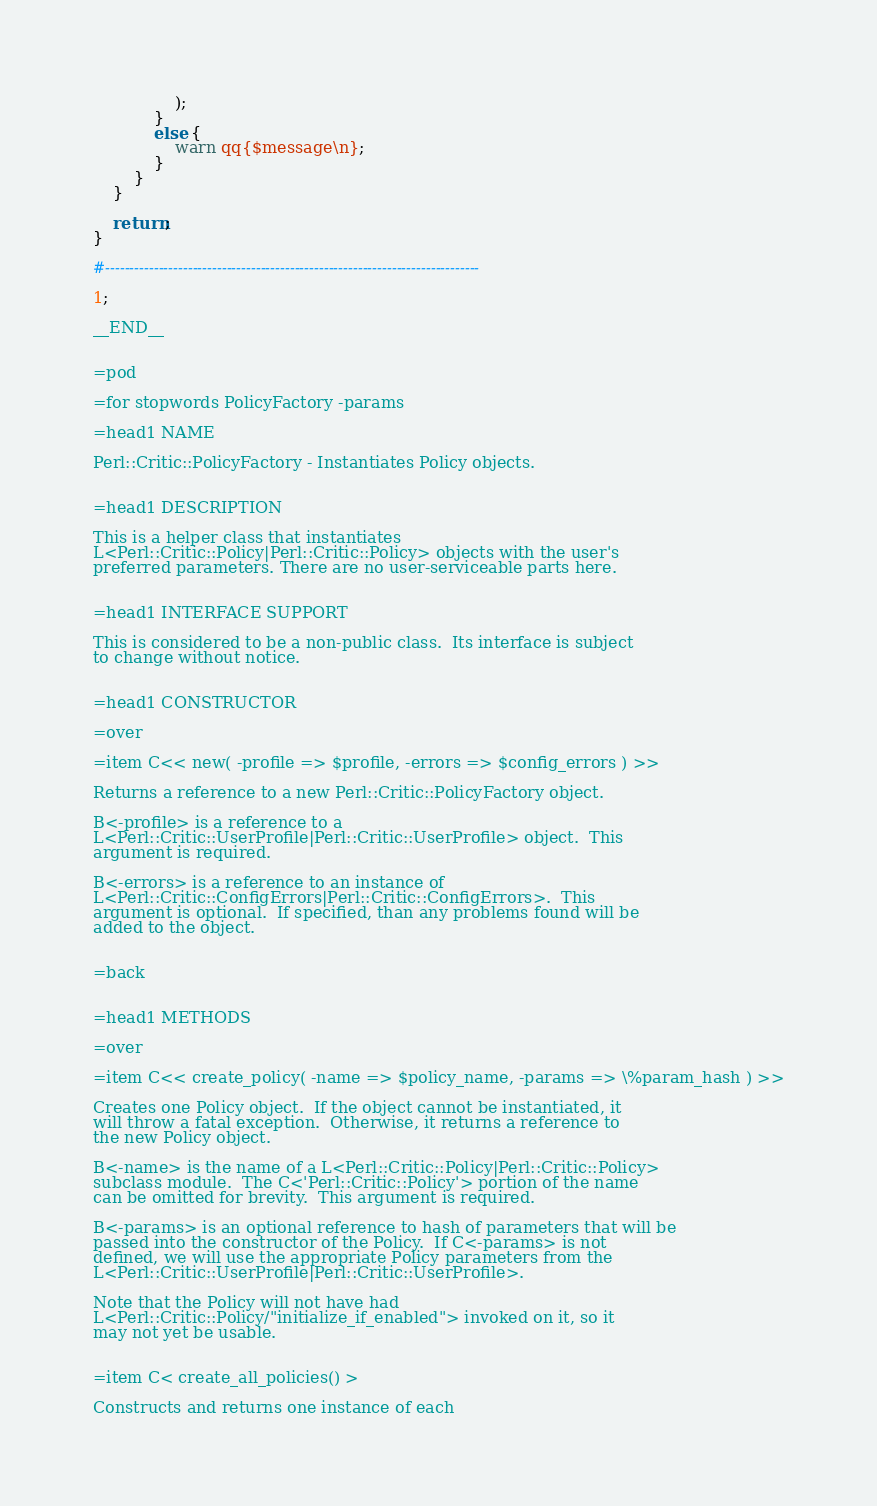Convert code to text. <code><loc_0><loc_0><loc_500><loc_500><_Perl_>                );
            }
            else {
                warn qq{$message\n};
            }
        }
    }

    return;
}

#-----------------------------------------------------------------------------

1;

__END__


=pod

=for stopwords PolicyFactory -params

=head1 NAME

Perl::Critic::PolicyFactory - Instantiates Policy objects.


=head1 DESCRIPTION

This is a helper class that instantiates
L<Perl::Critic::Policy|Perl::Critic::Policy> objects with the user's
preferred parameters. There are no user-serviceable parts here.


=head1 INTERFACE SUPPORT

This is considered to be a non-public class.  Its interface is subject
to change without notice.


=head1 CONSTRUCTOR

=over

=item C<< new( -profile => $profile, -errors => $config_errors ) >>

Returns a reference to a new Perl::Critic::PolicyFactory object.

B<-profile> is a reference to a
L<Perl::Critic::UserProfile|Perl::Critic::UserProfile> object.  This
argument is required.

B<-errors> is a reference to an instance of
L<Perl::Critic::ConfigErrors|Perl::Critic::ConfigErrors>.  This
argument is optional.  If specified, than any problems found will be
added to the object.


=back


=head1 METHODS

=over

=item C<< create_policy( -name => $policy_name, -params => \%param_hash ) >>

Creates one Policy object.  If the object cannot be instantiated, it
will throw a fatal exception.  Otherwise, it returns a reference to
the new Policy object.

B<-name> is the name of a L<Perl::Critic::Policy|Perl::Critic::Policy>
subclass module.  The C<'Perl::Critic::Policy'> portion of the name
can be omitted for brevity.  This argument is required.

B<-params> is an optional reference to hash of parameters that will be
passed into the constructor of the Policy.  If C<-params> is not
defined, we will use the appropriate Policy parameters from the
L<Perl::Critic::UserProfile|Perl::Critic::UserProfile>.

Note that the Policy will not have had
L<Perl::Critic::Policy/"initialize_if_enabled"> invoked on it, so it
may not yet be usable.


=item C< create_all_policies() >

Constructs and returns one instance of each</code> 